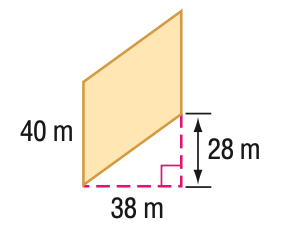Answer the mathemtical geometry problem and directly provide the correct option letter.
Question: Find the perimeter of the parallelogram. Round to the nearest tenth if necessary.
Choices: A: 132 B: 147.5 C: 156 D: 174.4 D 